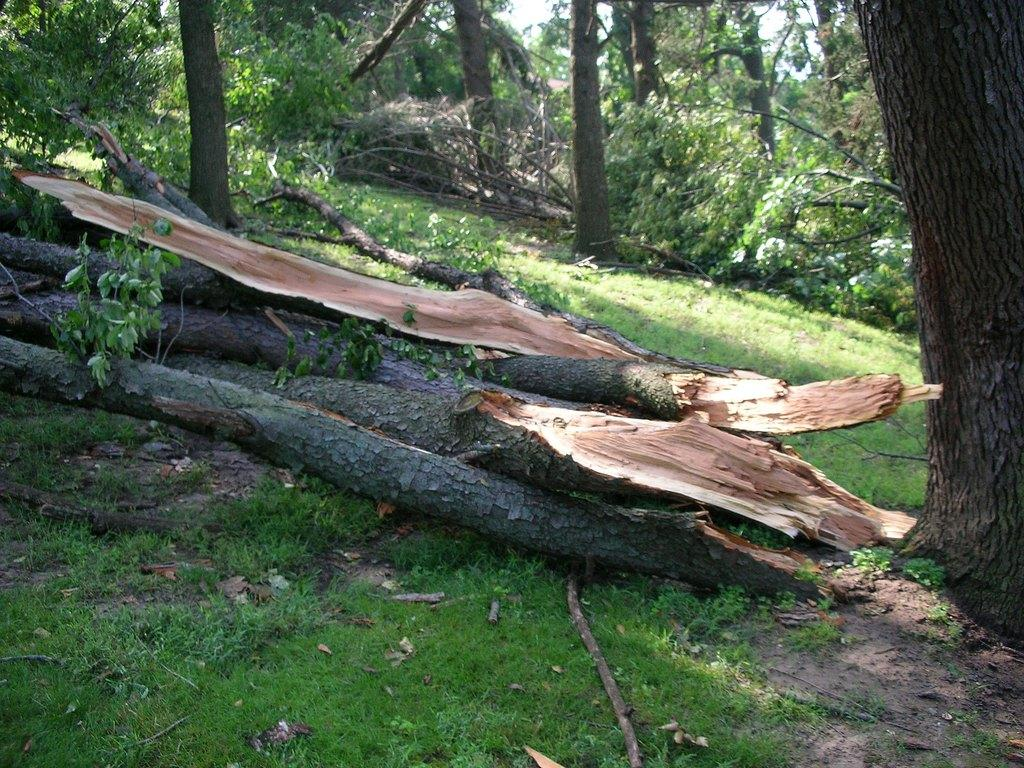What can be seen on the ground in the image? The ground is visible in the image, and there is grass on the ground. What objects are made of wood in the image? There are wooden logs in the image. What colors can be observed on the wooden logs? The wooden logs have cream, brown, and black colors. What is visible in the background of the image? There are trees and the sky visible in the background of the image. Can you tell me how many ducks are sitting on the ear of the person in the image? There is no person or ear present in the image, and therefore no ducks can be observed sitting on an ear. 